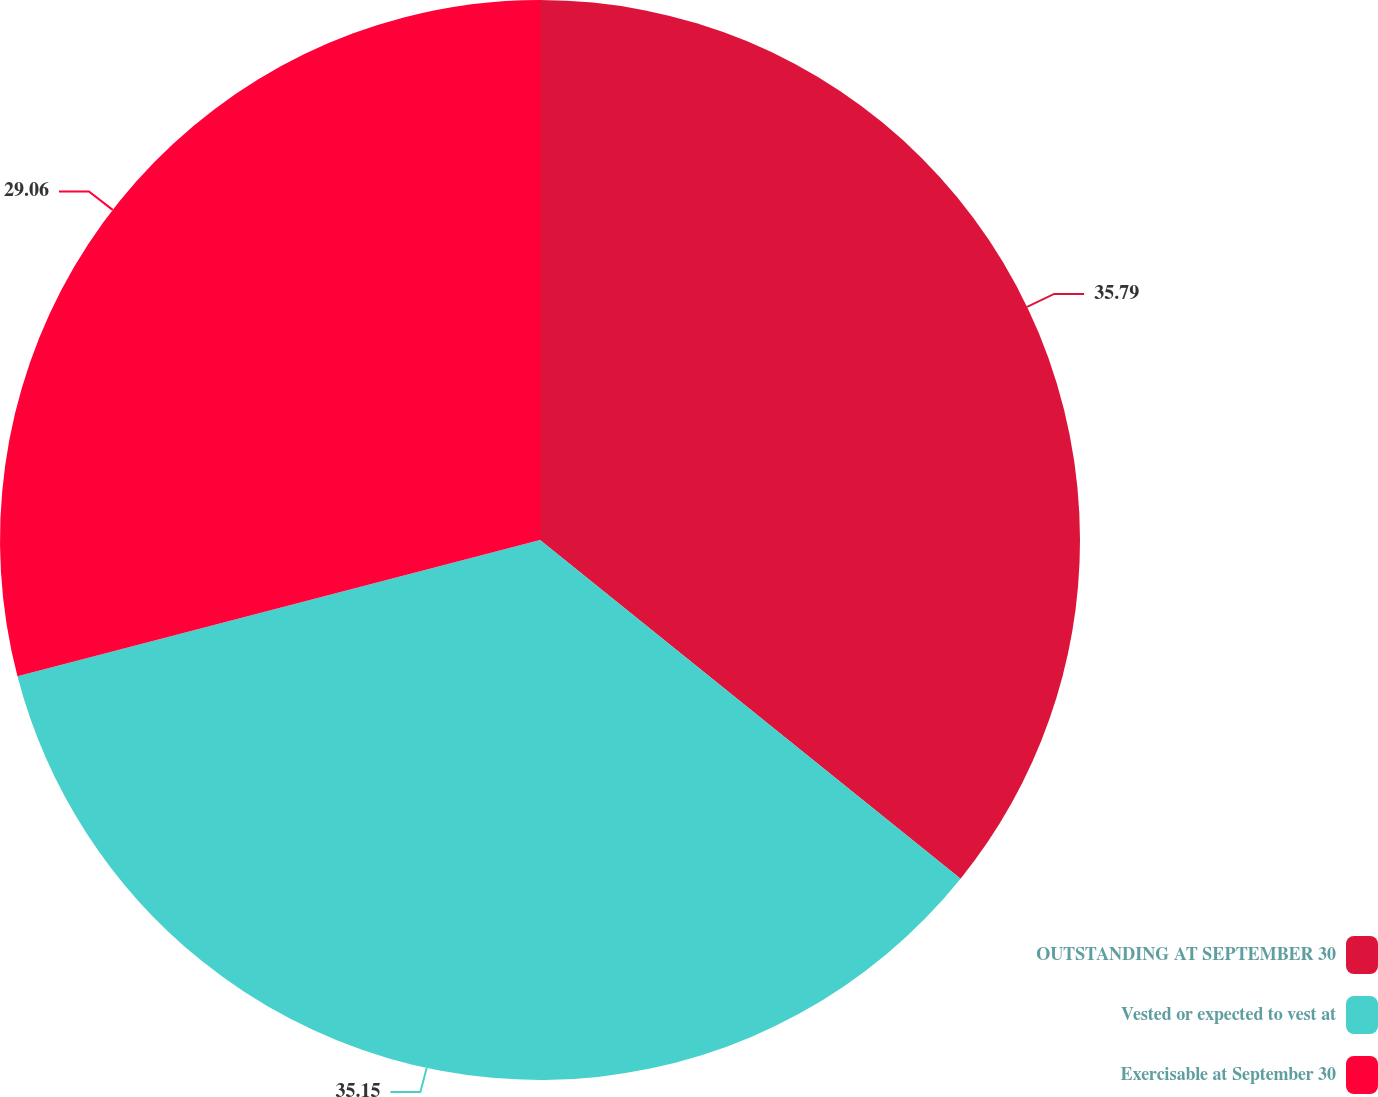Convert chart to OTSL. <chart><loc_0><loc_0><loc_500><loc_500><pie_chart><fcel>OUTSTANDING AT SEPTEMBER 30<fcel>Vested or expected to vest at<fcel>Exercisable at September 30<nl><fcel>35.79%<fcel>35.15%<fcel>29.06%<nl></chart> 